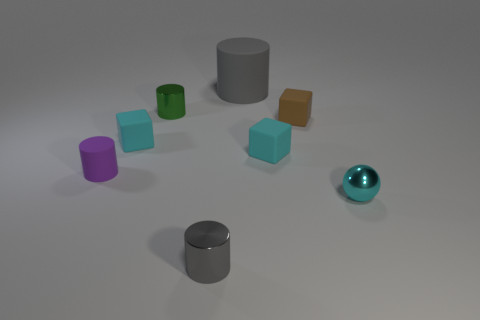Subtract all red cylinders. How many cyan cubes are left? 2 Subtract all cyan rubber cubes. How many cubes are left? 1 Subtract 1 blocks. How many blocks are left? 2 Add 1 small gray metal cylinders. How many objects exist? 9 Subtract all green cylinders. How many cylinders are left? 3 Subtract all purple blocks. Subtract all cyan spheres. How many blocks are left? 3 Subtract all cubes. How many objects are left? 5 Subtract 0 purple cubes. How many objects are left? 8 Subtract all large red rubber cubes. Subtract all small brown blocks. How many objects are left? 7 Add 5 cyan spheres. How many cyan spheres are left? 6 